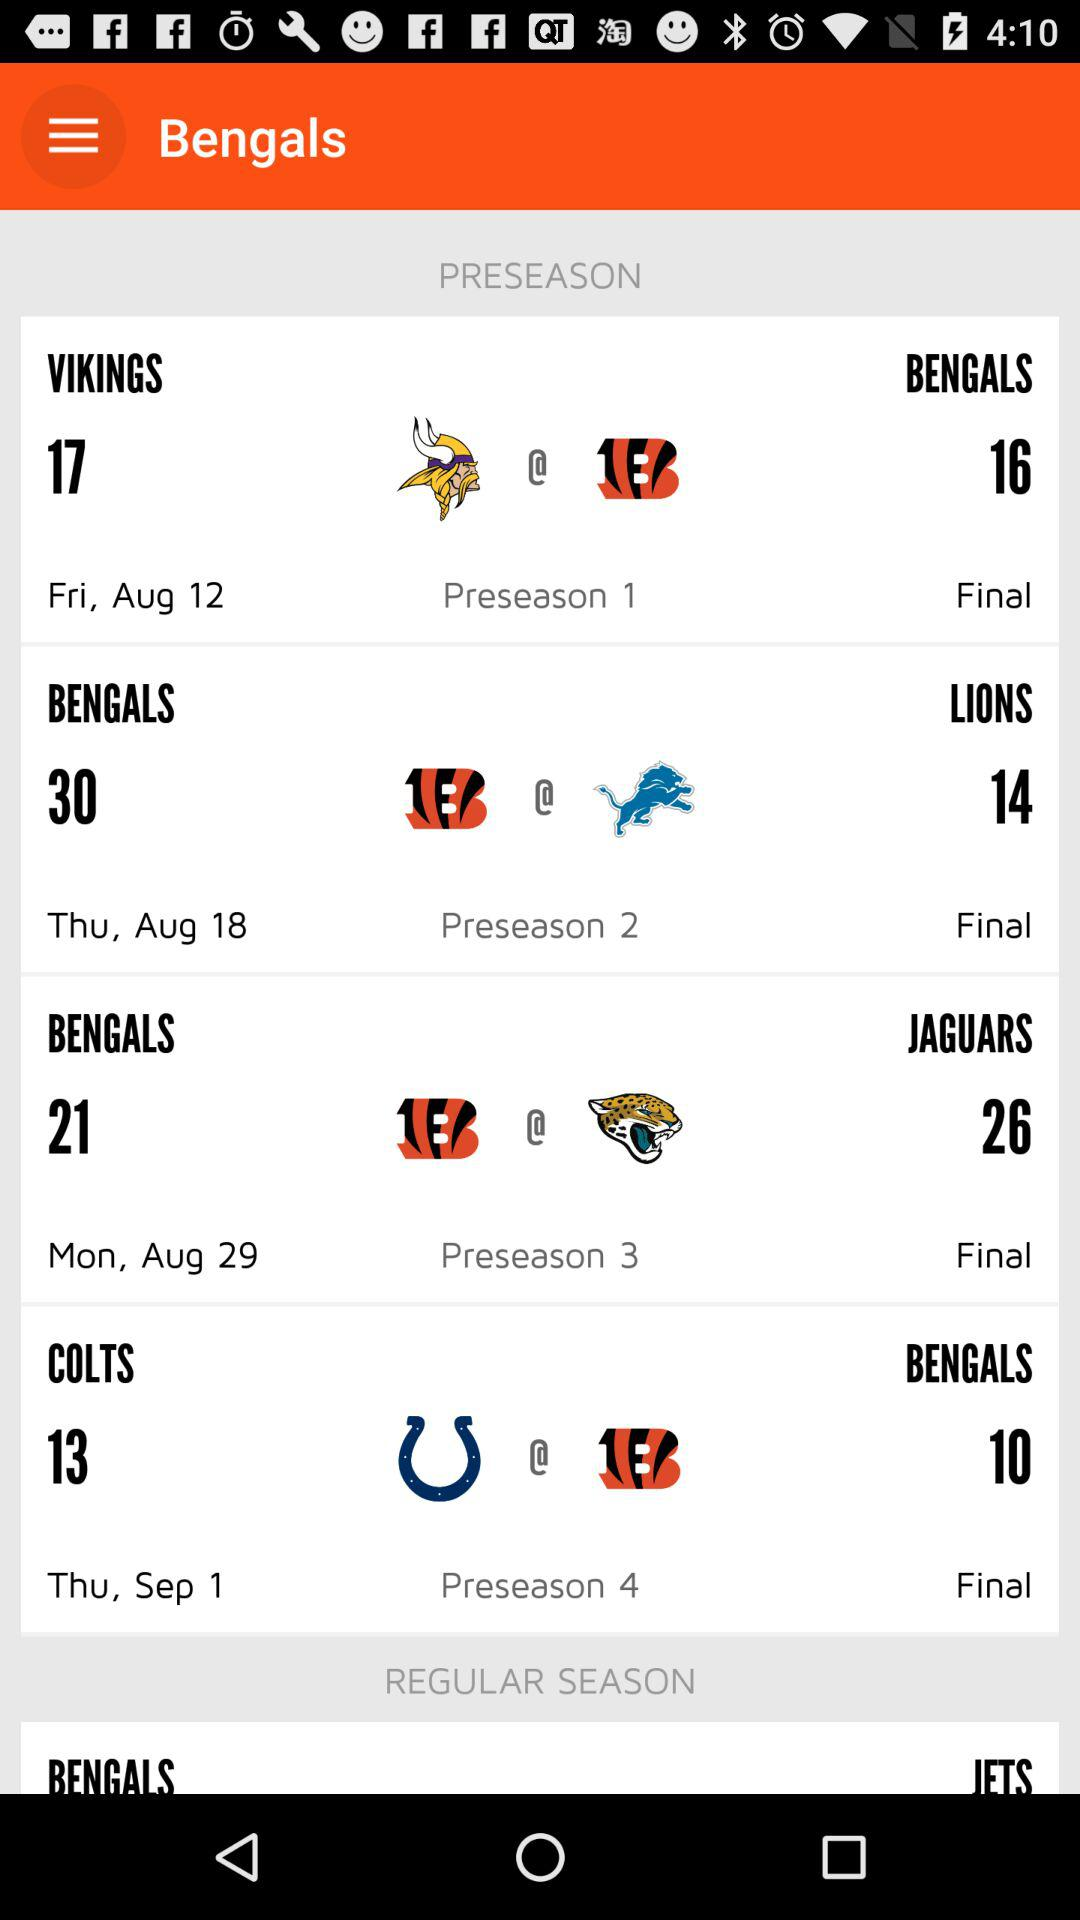How many preseason games are there?
Answer the question using a single word or phrase. 4 